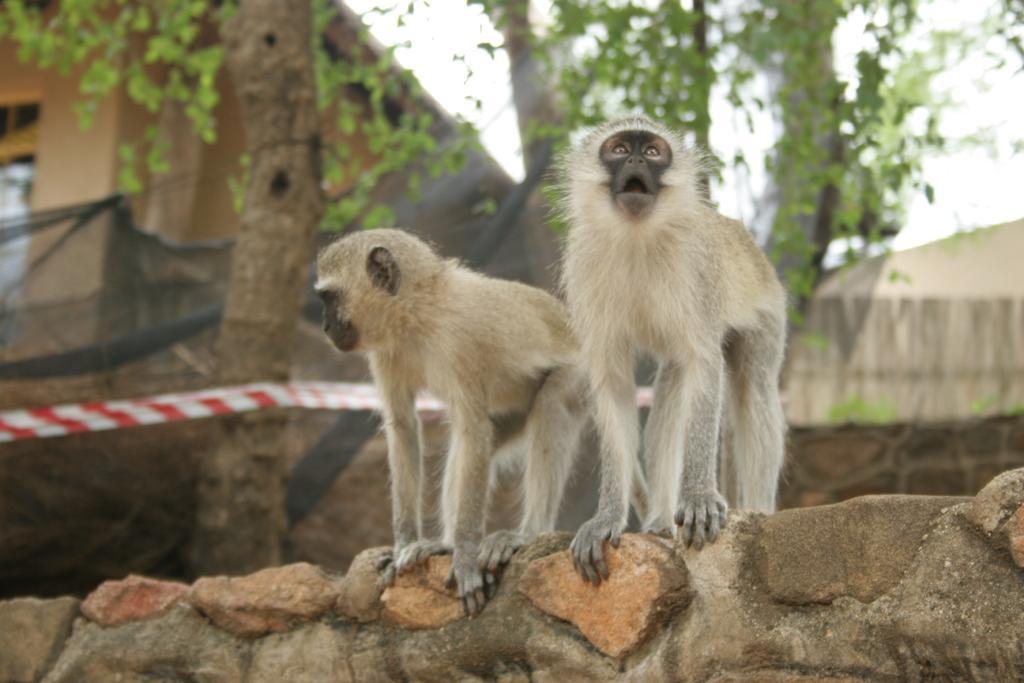In one or two sentences, can you explain what this image depicts? In this picture we can observe two monkeys which were in black and cream color. They were standing on the stone wall. In the background there are trees and a building. We can observe a sky. 